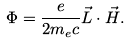Convert formula to latex. <formula><loc_0><loc_0><loc_500><loc_500>\Phi = \frac { e } { 2 m _ { e } c } \vec { L } \cdot \vec { H } .</formula> 